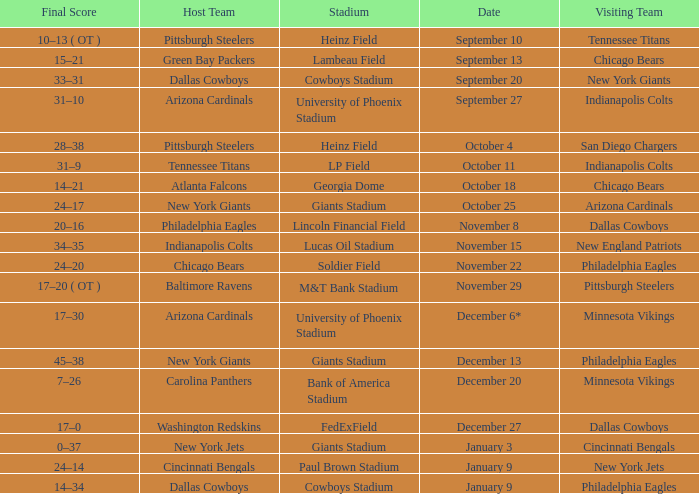I want to know the final score for december 27 17–0. 